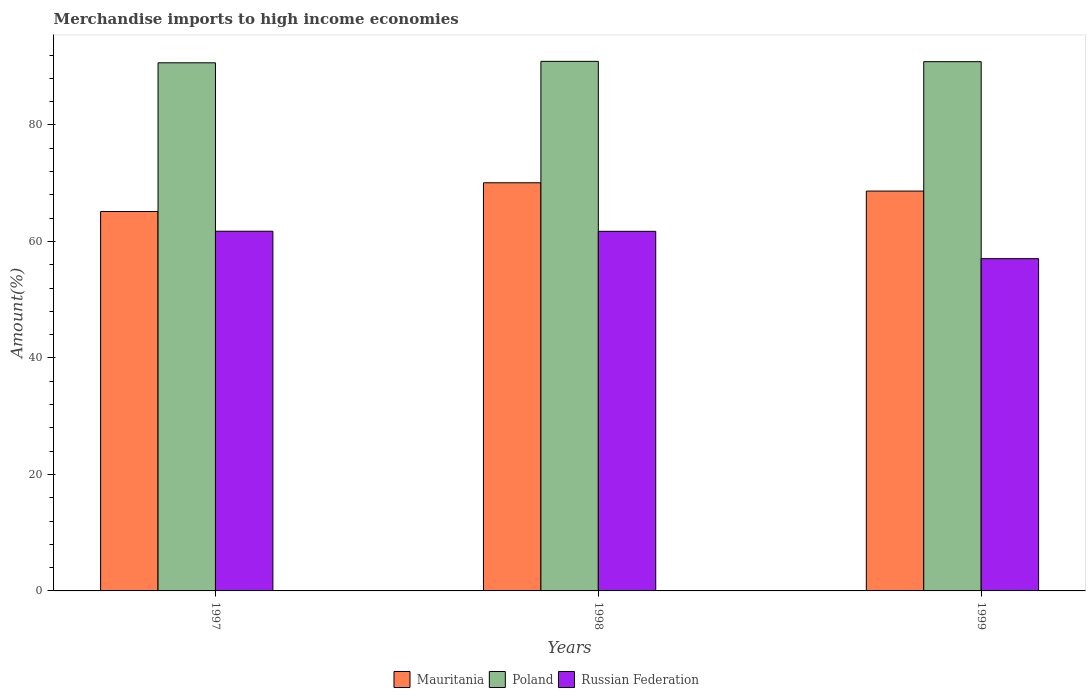How many different coloured bars are there?
Provide a succinct answer. 3. How many bars are there on the 3rd tick from the left?
Your response must be concise. 3. How many bars are there on the 3rd tick from the right?
Offer a very short reply. 3. What is the label of the 1st group of bars from the left?
Your answer should be compact. 1997. In how many cases, is the number of bars for a given year not equal to the number of legend labels?
Provide a short and direct response. 0. What is the percentage of amount earned from merchandise imports in Poland in 1997?
Make the answer very short. 90.66. Across all years, what is the maximum percentage of amount earned from merchandise imports in Poland?
Offer a terse response. 90.91. Across all years, what is the minimum percentage of amount earned from merchandise imports in Mauritania?
Keep it short and to the point. 65.13. In which year was the percentage of amount earned from merchandise imports in Poland minimum?
Make the answer very short. 1997. What is the total percentage of amount earned from merchandise imports in Mauritania in the graph?
Make the answer very short. 203.85. What is the difference between the percentage of amount earned from merchandise imports in Mauritania in 1997 and that in 1999?
Your answer should be compact. -3.51. What is the difference between the percentage of amount earned from merchandise imports in Poland in 1998 and the percentage of amount earned from merchandise imports in Russian Federation in 1997?
Your answer should be very brief. 29.16. What is the average percentage of amount earned from merchandise imports in Mauritania per year?
Your answer should be very brief. 67.95. In the year 1998, what is the difference between the percentage of amount earned from merchandise imports in Mauritania and percentage of amount earned from merchandise imports in Russian Federation?
Offer a very short reply. 8.33. What is the ratio of the percentage of amount earned from merchandise imports in Mauritania in 1997 to that in 1999?
Your answer should be compact. 0.95. Is the percentage of amount earned from merchandise imports in Mauritania in 1997 less than that in 1999?
Ensure brevity in your answer.  Yes. Is the difference between the percentage of amount earned from merchandise imports in Mauritania in 1997 and 1999 greater than the difference between the percentage of amount earned from merchandise imports in Russian Federation in 1997 and 1999?
Provide a succinct answer. No. What is the difference between the highest and the second highest percentage of amount earned from merchandise imports in Mauritania?
Provide a short and direct response. 1.43. What is the difference between the highest and the lowest percentage of amount earned from merchandise imports in Poland?
Provide a short and direct response. 0.25. What does the 1st bar from the left in 1999 represents?
Provide a short and direct response. Mauritania. What does the 3rd bar from the right in 1999 represents?
Your answer should be very brief. Mauritania. Is it the case that in every year, the sum of the percentage of amount earned from merchandise imports in Russian Federation and percentage of amount earned from merchandise imports in Poland is greater than the percentage of amount earned from merchandise imports in Mauritania?
Keep it short and to the point. Yes. How many years are there in the graph?
Keep it short and to the point. 3. Are the values on the major ticks of Y-axis written in scientific E-notation?
Your answer should be very brief. No. Does the graph contain any zero values?
Offer a very short reply. No. Does the graph contain grids?
Provide a succinct answer. No. Where does the legend appear in the graph?
Provide a short and direct response. Bottom center. What is the title of the graph?
Provide a succinct answer. Merchandise imports to high income economies. Does "Dominican Republic" appear as one of the legend labels in the graph?
Ensure brevity in your answer.  No. What is the label or title of the X-axis?
Your answer should be very brief. Years. What is the label or title of the Y-axis?
Provide a short and direct response. Amount(%). What is the Amount(%) in Mauritania in 1997?
Give a very brief answer. 65.13. What is the Amount(%) of Poland in 1997?
Provide a succinct answer. 90.66. What is the Amount(%) of Russian Federation in 1997?
Offer a terse response. 61.75. What is the Amount(%) in Mauritania in 1998?
Keep it short and to the point. 70.07. What is the Amount(%) in Poland in 1998?
Make the answer very short. 90.91. What is the Amount(%) in Russian Federation in 1998?
Provide a succinct answer. 61.73. What is the Amount(%) of Mauritania in 1999?
Keep it short and to the point. 68.64. What is the Amount(%) of Poland in 1999?
Your response must be concise. 90.86. What is the Amount(%) of Russian Federation in 1999?
Offer a very short reply. 57.04. Across all years, what is the maximum Amount(%) of Mauritania?
Your answer should be very brief. 70.07. Across all years, what is the maximum Amount(%) of Poland?
Ensure brevity in your answer.  90.91. Across all years, what is the maximum Amount(%) in Russian Federation?
Your response must be concise. 61.75. Across all years, what is the minimum Amount(%) of Mauritania?
Make the answer very short. 65.13. Across all years, what is the minimum Amount(%) in Poland?
Your response must be concise. 90.66. Across all years, what is the minimum Amount(%) of Russian Federation?
Offer a very short reply. 57.04. What is the total Amount(%) in Mauritania in the graph?
Make the answer very short. 203.85. What is the total Amount(%) in Poland in the graph?
Your answer should be very brief. 272.43. What is the total Amount(%) of Russian Federation in the graph?
Your response must be concise. 180.52. What is the difference between the Amount(%) of Mauritania in 1997 and that in 1998?
Offer a very short reply. -4.93. What is the difference between the Amount(%) of Poland in 1997 and that in 1998?
Ensure brevity in your answer.  -0.25. What is the difference between the Amount(%) of Russian Federation in 1997 and that in 1998?
Your response must be concise. 0.02. What is the difference between the Amount(%) in Mauritania in 1997 and that in 1999?
Your response must be concise. -3.51. What is the difference between the Amount(%) in Poland in 1997 and that in 1999?
Your response must be concise. -0.19. What is the difference between the Amount(%) in Russian Federation in 1997 and that in 1999?
Your answer should be very brief. 4.71. What is the difference between the Amount(%) of Mauritania in 1998 and that in 1999?
Your answer should be compact. 1.43. What is the difference between the Amount(%) in Poland in 1998 and that in 1999?
Provide a succinct answer. 0.06. What is the difference between the Amount(%) in Russian Federation in 1998 and that in 1999?
Provide a succinct answer. 4.69. What is the difference between the Amount(%) of Mauritania in 1997 and the Amount(%) of Poland in 1998?
Your answer should be compact. -25.78. What is the difference between the Amount(%) in Mauritania in 1997 and the Amount(%) in Russian Federation in 1998?
Your answer should be very brief. 3.4. What is the difference between the Amount(%) of Poland in 1997 and the Amount(%) of Russian Federation in 1998?
Your answer should be very brief. 28.93. What is the difference between the Amount(%) in Mauritania in 1997 and the Amount(%) in Poland in 1999?
Give a very brief answer. -25.72. What is the difference between the Amount(%) of Mauritania in 1997 and the Amount(%) of Russian Federation in 1999?
Your response must be concise. 8.09. What is the difference between the Amount(%) of Poland in 1997 and the Amount(%) of Russian Federation in 1999?
Your answer should be very brief. 33.62. What is the difference between the Amount(%) of Mauritania in 1998 and the Amount(%) of Poland in 1999?
Your response must be concise. -20.79. What is the difference between the Amount(%) in Mauritania in 1998 and the Amount(%) in Russian Federation in 1999?
Provide a succinct answer. 13.03. What is the difference between the Amount(%) in Poland in 1998 and the Amount(%) in Russian Federation in 1999?
Provide a succinct answer. 33.87. What is the average Amount(%) in Mauritania per year?
Your answer should be very brief. 67.95. What is the average Amount(%) of Poland per year?
Ensure brevity in your answer.  90.81. What is the average Amount(%) in Russian Federation per year?
Give a very brief answer. 60.17. In the year 1997, what is the difference between the Amount(%) in Mauritania and Amount(%) in Poland?
Your response must be concise. -25.53. In the year 1997, what is the difference between the Amount(%) in Mauritania and Amount(%) in Russian Federation?
Offer a very short reply. 3.38. In the year 1997, what is the difference between the Amount(%) of Poland and Amount(%) of Russian Federation?
Provide a short and direct response. 28.91. In the year 1998, what is the difference between the Amount(%) of Mauritania and Amount(%) of Poland?
Offer a very short reply. -20.84. In the year 1998, what is the difference between the Amount(%) in Mauritania and Amount(%) in Russian Federation?
Provide a short and direct response. 8.33. In the year 1998, what is the difference between the Amount(%) in Poland and Amount(%) in Russian Federation?
Your answer should be very brief. 29.18. In the year 1999, what is the difference between the Amount(%) of Mauritania and Amount(%) of Poland?
Your response must be concise. -22.21. In the year 1999, what is the difference between the Amount(%) of Mauritania and Amount(%) of Russian Federation?
Give a very brief answer. 11.6. In the year 1999, what is the difference between the Amount(%) of Poland and Amount(%) of Russian Federation?
Give a very brief answer. 33.81. What is the ratio of the Amount(%) in Mauritania in 1997 to that in 1998?
Provide a succinct answer. 0.93. What is the ratio of the Amount(%) of Poland in 1997 to that in 1998?
Give a very brief answer. 1. What is the ratio of the Amount(%) of Russian Federation in 1997 to that in 1998?
Give a very brief answer. 1. What is the ratio of the Amount(%) of Mauritania in 1997 to that in 1999?
Your response must be concise. 0.95. What is the ratio of the Amount(%) in Russian Federation in 1997 to that in 1999?
Your answer should be compact. 1.08. What is the ratio of the Amount(%) in Mauritania in 1998 to that in 1999?
Give a very brief answer. 1.02. What is the ratio of the Amount(%) of Poland in 1998 to that in 1999?
Offer a terse response. 1. What is the ratio of the Amount(%) of Russian Federation in 1998 to that in 1999?
Your answer should be very brief. 1.08. What is the difference between the highest and the second highest Amount(%) of Mauritania?
Your answer should be very brief. 1.43. What is the difference between the highest and the second highest Amount(%) in Poland?
Your answer should be compact. 0.06. What is the difference between the highest and the second highest Amount(%) of Russian Federation?
Provide a short and direct response. 0.02. What is the difference between the highest and the lowest Amount(%) in Mauritania?
Keep it short and to the point. 4.93. What is the difference between the highest and the lowest Amount(%) in Poland?
Offer a terse response. 0.25. What is the difference between the highest and the lowest Amount(%) in Russian Federation?
Offer a terse response. 4.71. 